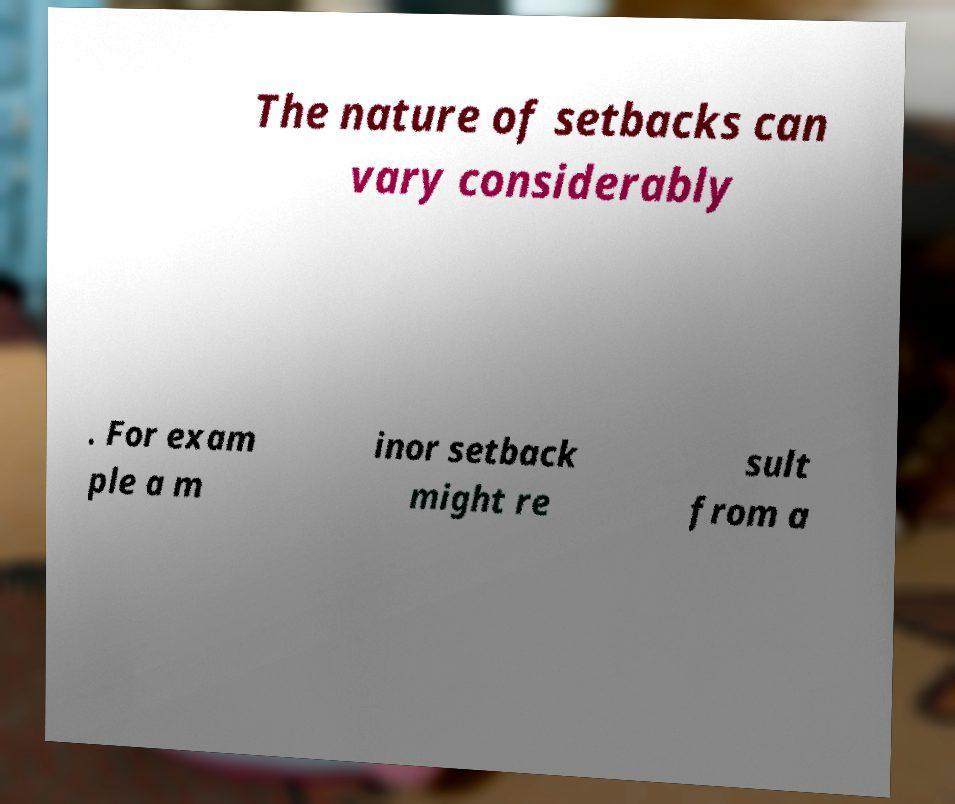Can you accurately transcribe the text from the provided image for me? The nature of setbacks can vary considerably . For exam ple a m inor setback might re sult from a 